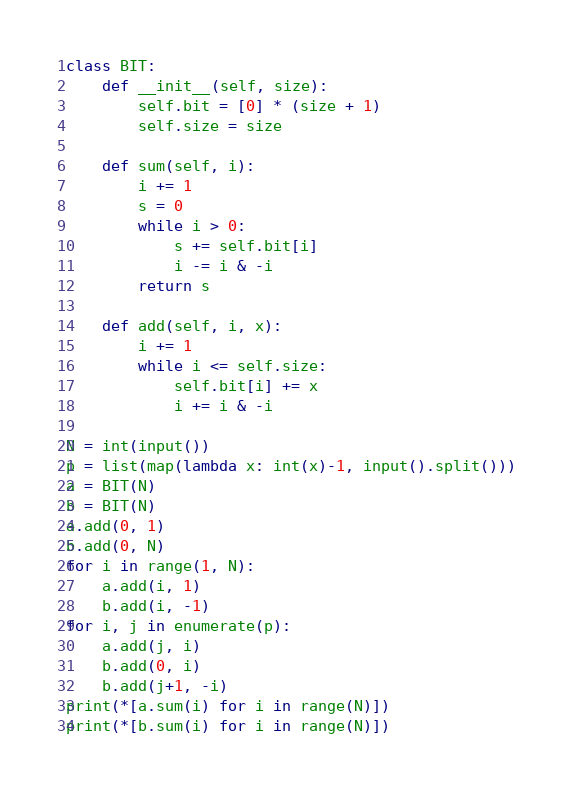Convert code to text. <code><loc_0><loc_0><loc_500><loc_500><_Python_>class BIT:
    def __init__(self, size):
        self.bit = [0] * (size + 1)
        self.size = size

    def sum(self, i):
        i += 1
        s = 0
        while i > 0:
            s += self.bit[i]
            i -= i & -i
        return s

    def add(self, i, x):
        i += 1
        while i <= self.size:
            self.bit[i] += x
            i += i & -i

N = int(input())
p = list(map(lambda x: int(x)-1, input().split()))
a = BIT(N)
b = BIT(N)
a.add(0, 1)
b.add(0, N)
for i in range(1, N):
    a.add(i, 1)
    b.add(i, -1)
for i, j in enumerate(p):
    a.add(j, i)
    b.add(0, i)
    b.add(j+1, -i)
print(*[a.sum(i) for i in range(N)])
print(*[b.sum(i) for i in range(N)])</code> 